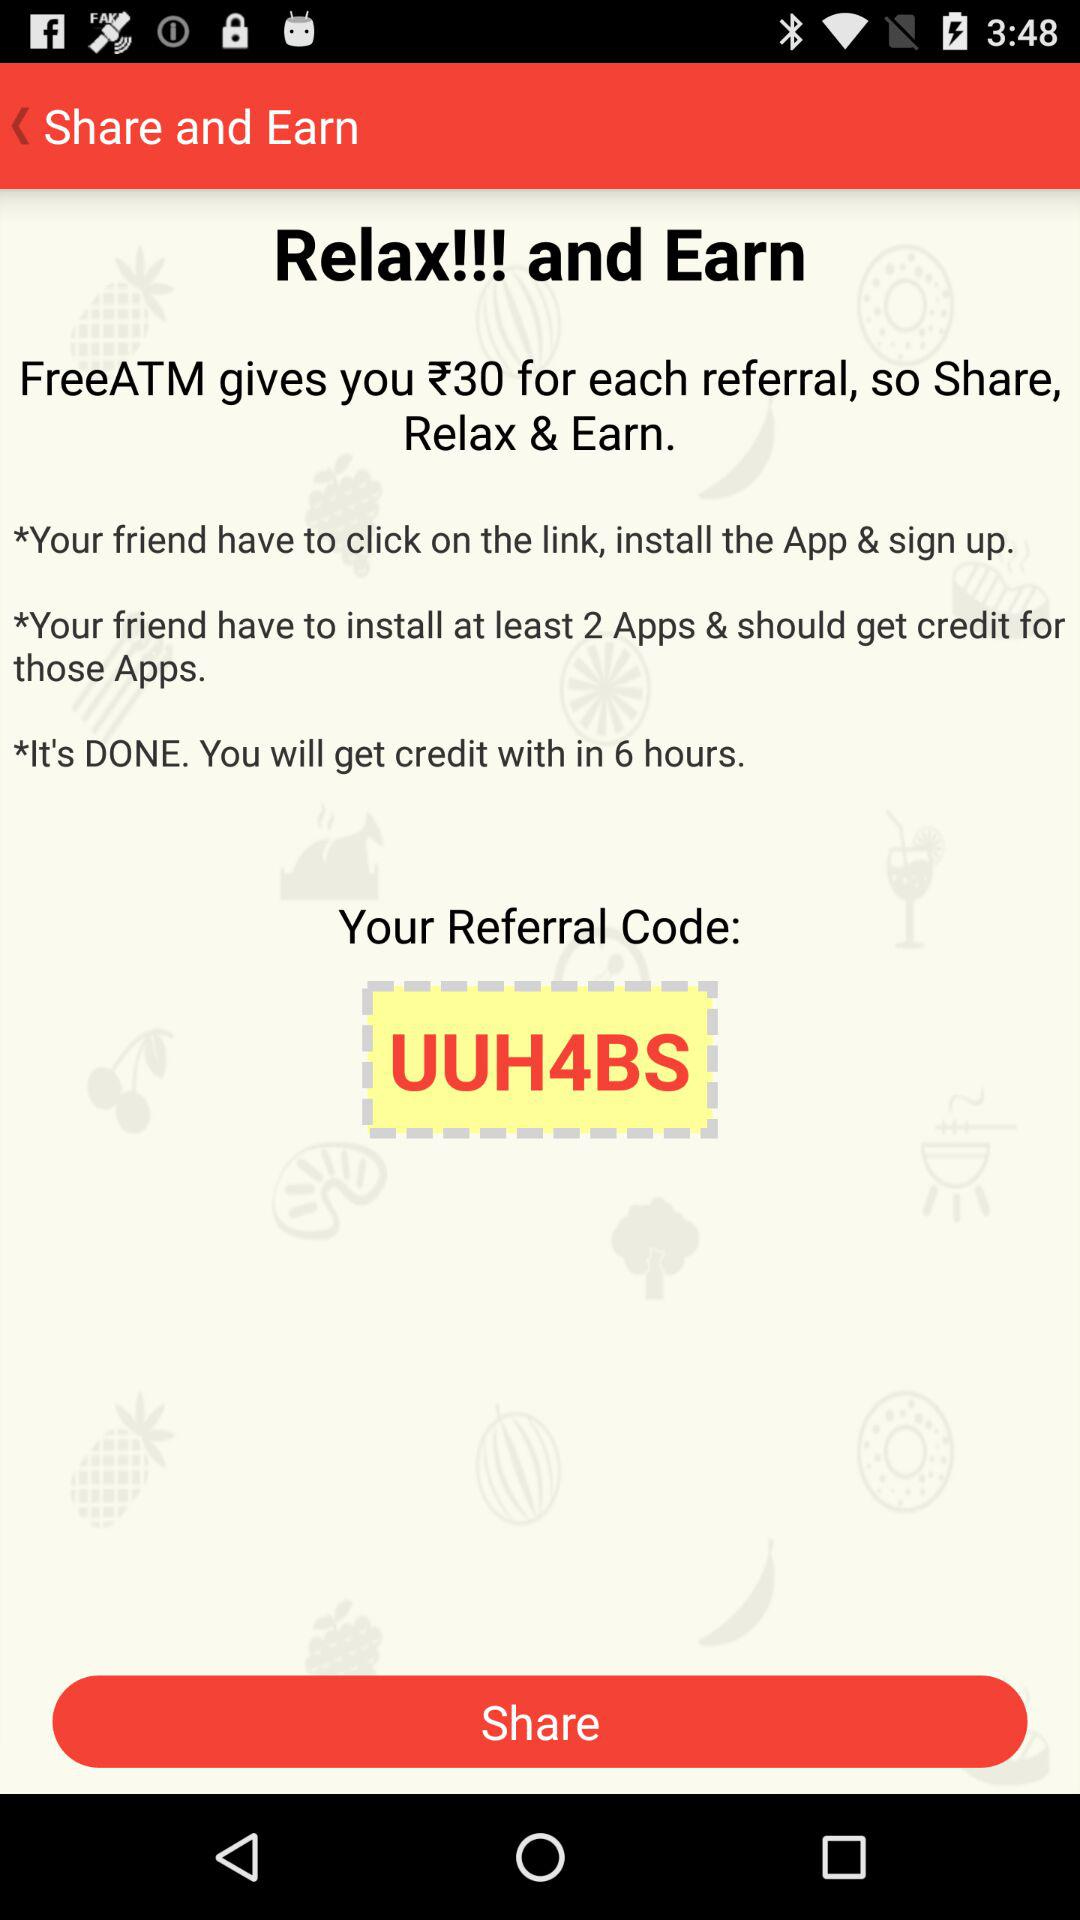How many rules are there in total?
Answer the question using a single word or phrase. 3 